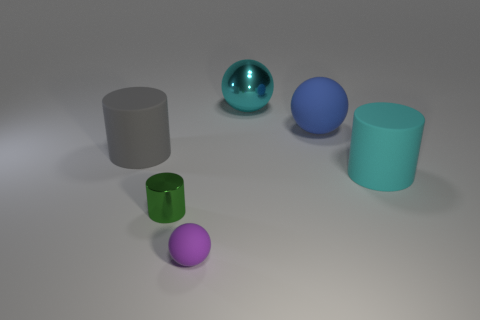Add 4 spheres. How many objects exist? 10 Subtract all small gray metal balls. Subtract all small balls. How many objects are left? 5 Add 4 cyan metal things. How many cyan metal things are left? 5 Add 5 tiny green objects. How many tiny green objects exist? 6 Subtract 1 purple balls. How many objects are left? 5 